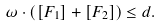Convert formula to latex. <formula><loc_0><loc_0><loc_500><loc_500>\omega \cdot ( [ F _ { 1 } ] + [ F _ { 2 } ] ) \leq d .</formula> 